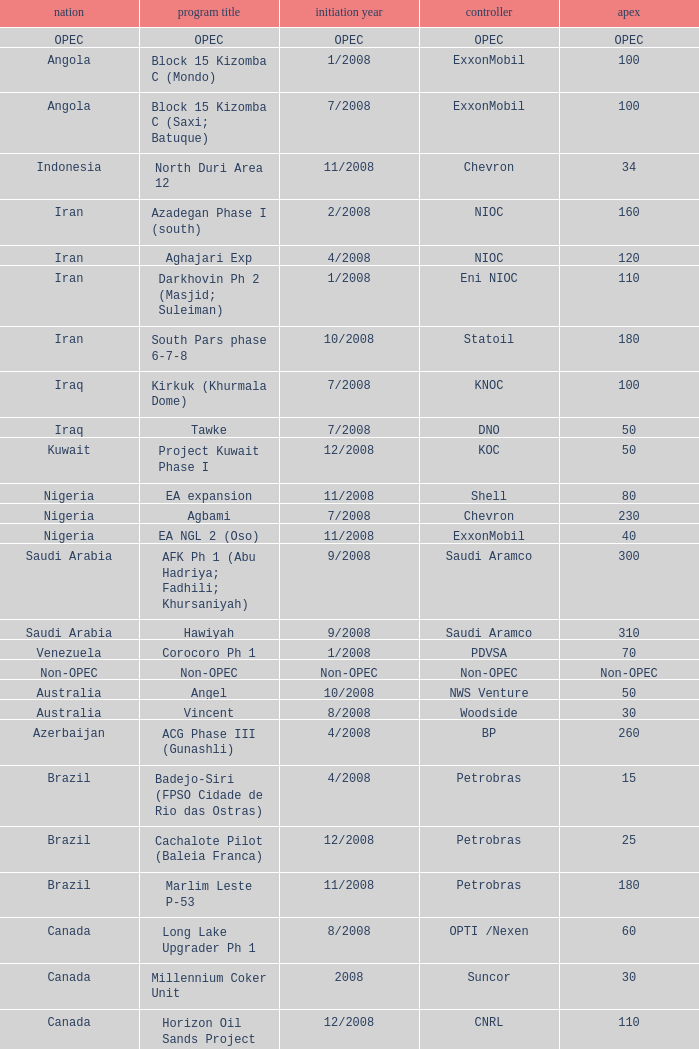What is the Project Name with a Country that is kazakhstan and a Peak that is 150? Dunga. 